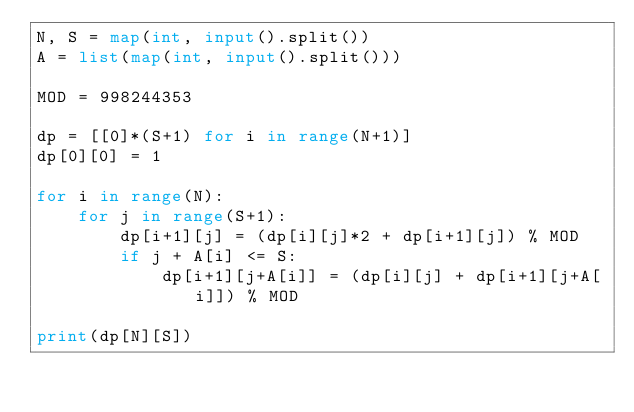Convert code to text. <code><loc_0><loc_0><loc_500><loc_500><_Python_>N, S = map(int, input().split())
A = list(map(int, input().split()))

MOD = 998244353

dp = [[0]*(S+1) for i in range(N+1)]
dp[0][0] = 1

for i in range(N):
    for j in range(S+1):
        dp[i+1][j] = (dp[i][j]*2 + dp[i+1][j]) % MOD
        if j + A[i] <= S:
            dp[i+1][j+A[i]] = (dp[i][j] + dp[i+1][j+A[i]]) % MOD

print(dp[N][S])</code> 